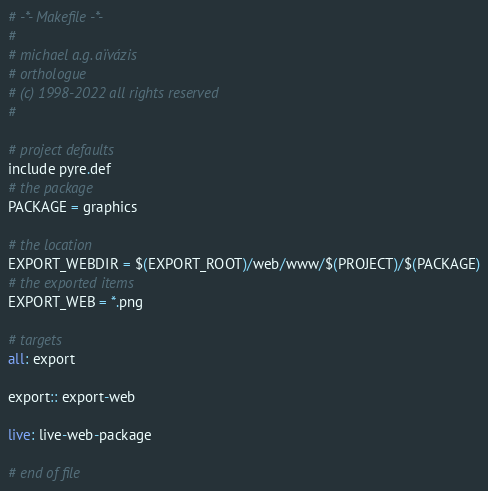Convert code to text. <code><loc_0><loc_0><loc_500><loc_500><_ObjectiveC_># -*- Makefile -*-
#
# michael a.g. aïvázis
# orthologue
# (c) 1998-2022 all rights reserved
#

# project defaults
include pyre.def
# the package
PACKAGE = graphics

# the location
EXPORT_WEBDIR = $(EXPORT_ROOT)/web/www/$(PROJECT)/$(PACKAGE)
# the exported items
EXPORT_WEB = *.png

# targets
all: export

export:: export-web

live: live-web-package

# end of file
</code> 